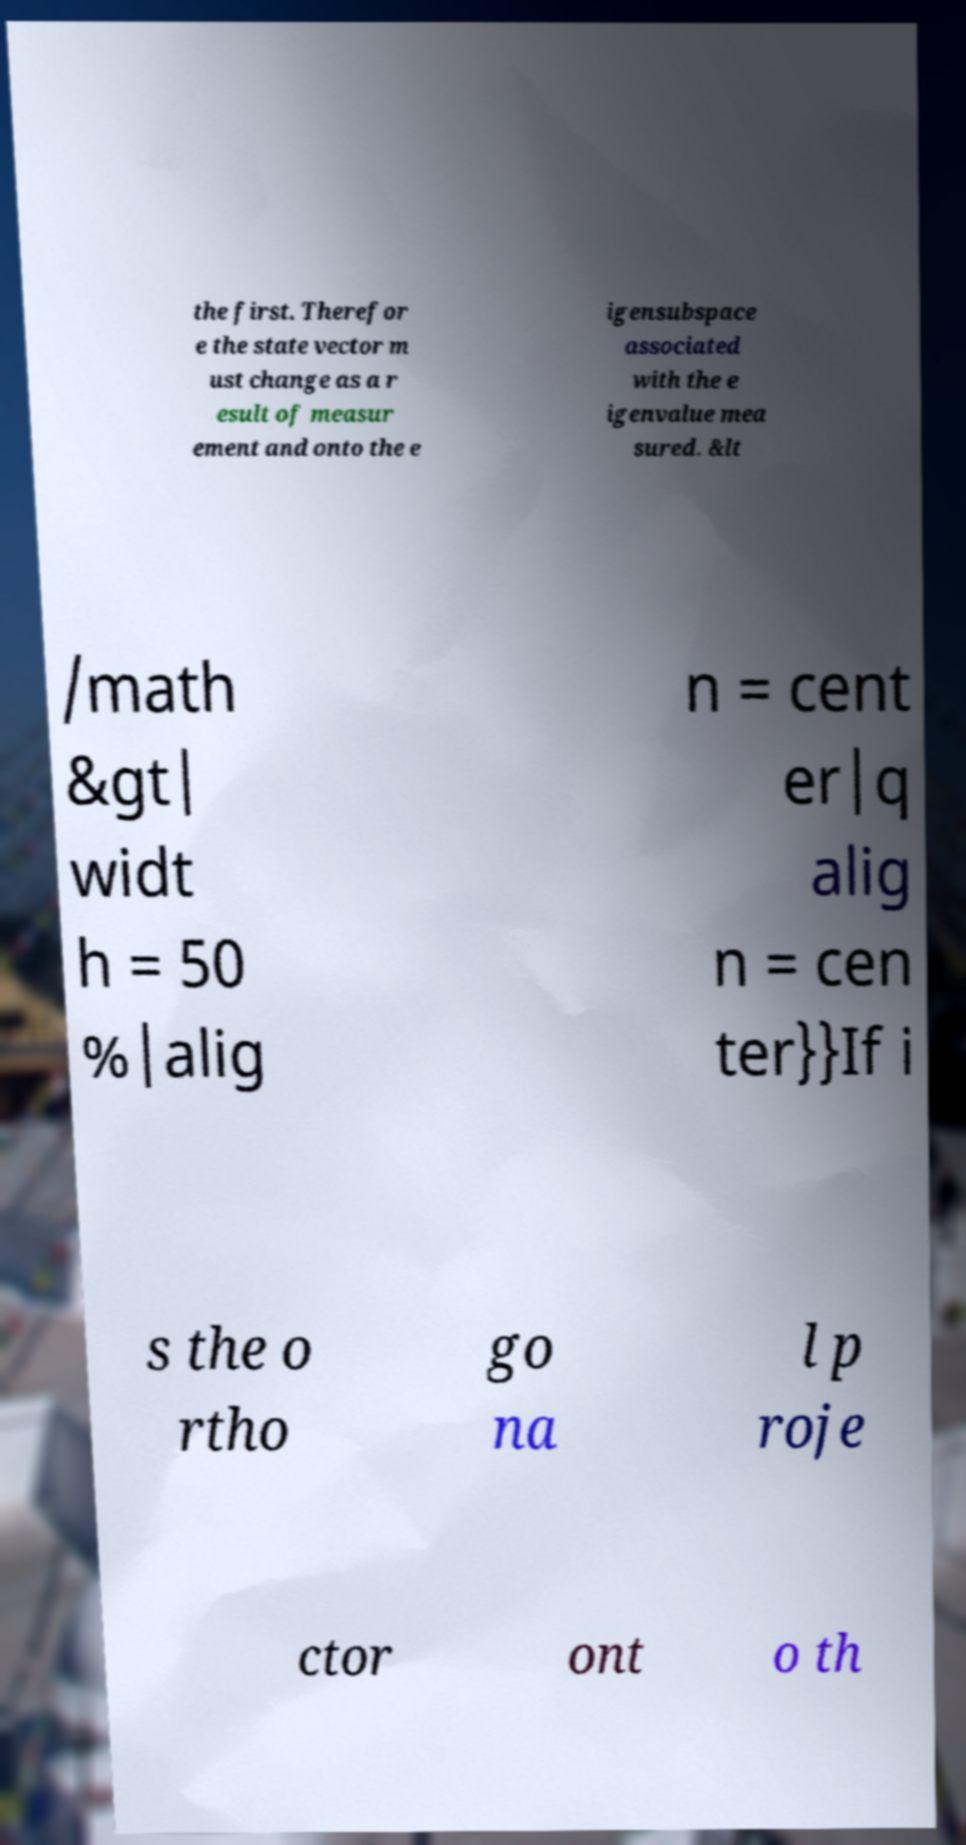Can you accurately transcribe the text from the provided image for me? the first. Therefor e the state vector m ust change as a r esult of measur ement and onto the e igensubspace associated with the e igenvalue mea sured. &lt /math &gt| widt h = 50 %|alig n = cent er|q alig n = cen ter}}If i s the o rtho go na l p roje ctor ont o th 